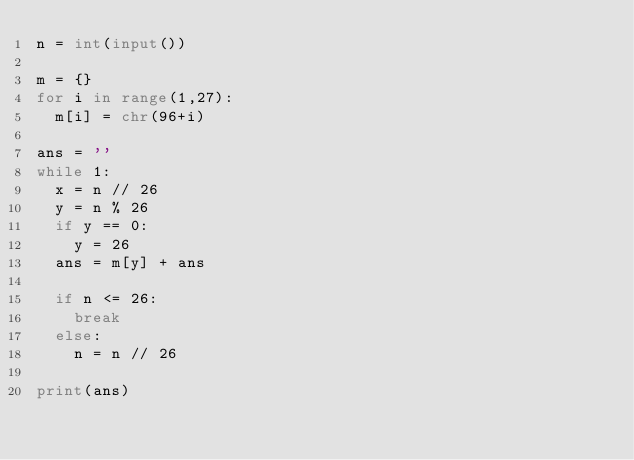<code> <loc_0><loc_0><loc_500><loc_500><_Python_>n = int(input())

m = {}
for i in range(1,27):
  m[i] = chr(96+i)

ans = ''
while 1:
  x = n // 26
  y = n % 26
  if y == 0:
    y = 26
  ans = m[y] + ans
  
  if n <= 26:
    break
  else:
    n = n // 26

print(ans)
</code> 